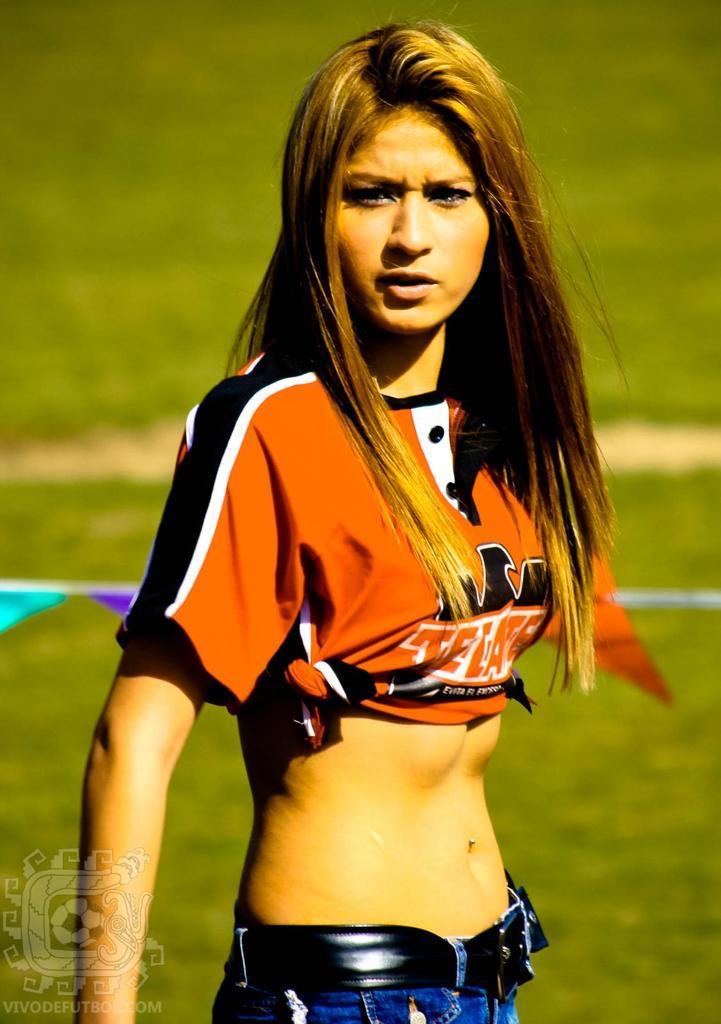Can you describe this image briefly? In this image we can see a woman standing. In the background we can see the plants and also the grass. In the bottom left corner we can see the logo and also the text. 